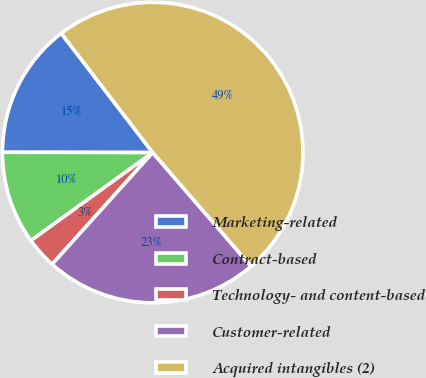Convert chart to OTSL. <chart><loc_0><loc_0><loc_500><loc_500><pie_chart><fcel>Marketing-related<fcel>Contract-based<fcel>Technology- and content-based<fcel>Customer-related<fcel>Acquired intangibles (2)<nl><fcel>14.56%<fcel>9.99%<fcel>3.37%<fcel>23.02%<fcel>49.06%<nl></chart> 